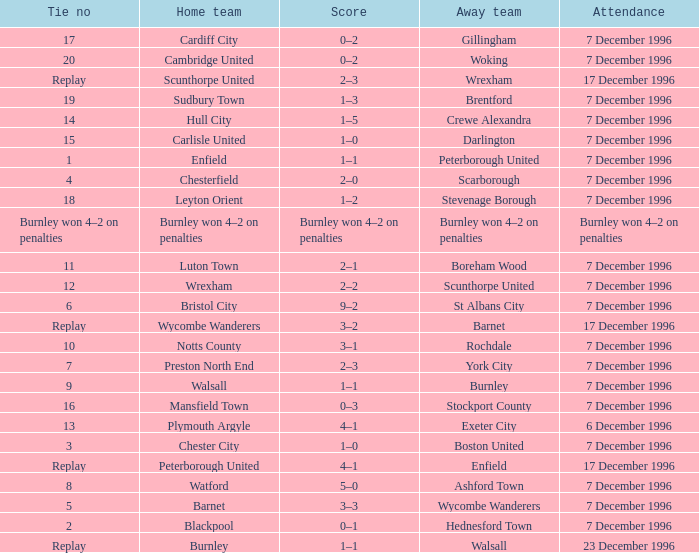What was the score of tie number 15? 1–0. 